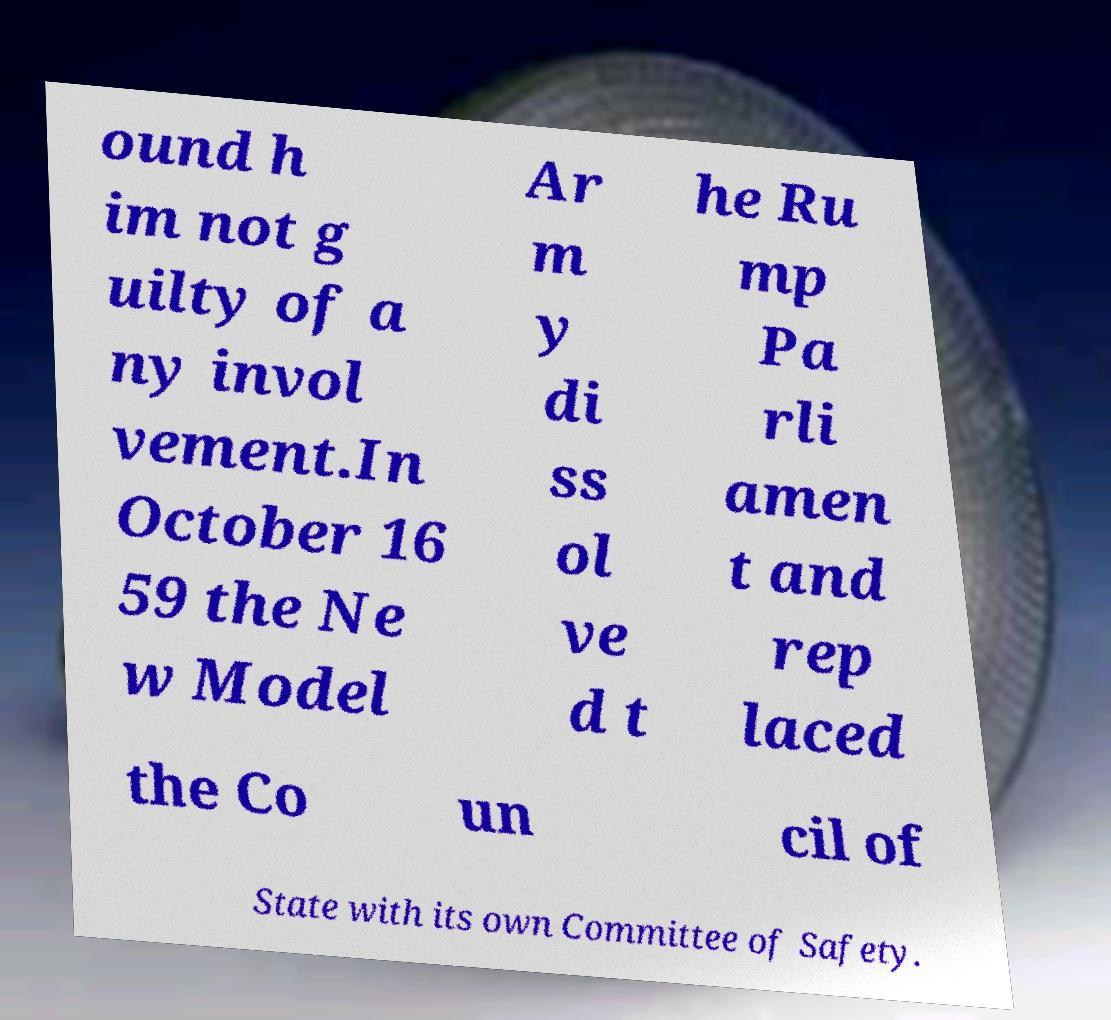Could you assist in decoding the text presented in this image and type it out clearly? ound h im not g uilty of a ny invol vement.In October 16 59 the Ne w Model Ar m y di ss ol ve d t he Ru mp Pa rli amen t and rep laced the Co un cil of State with its own Committee of Safety. 